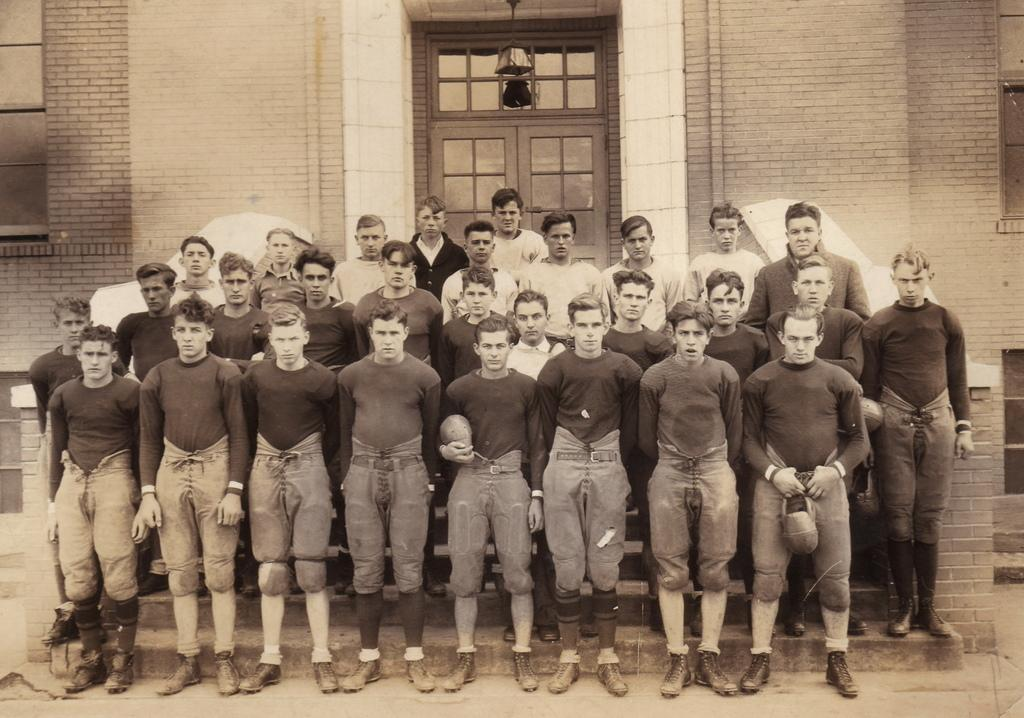What type of photograph is in the image? The image contains a black and white photograph. Who or what is depicted in the photograph? There is a group of people in the photograph. What are the people in the photograph wearing? The people in the photograph are wearing the same dresses. What can be seen in the background of the photograph? There is a wall with a door in the background of the photograph. What type of bone can be seen in the hands of the people in the image? There is no bone present in the image; it is a photograph of people wearing dresses. Who is the expert in the field of dresses in the image? There is no indication in the image that any of the people are experts in the field of dresses. 